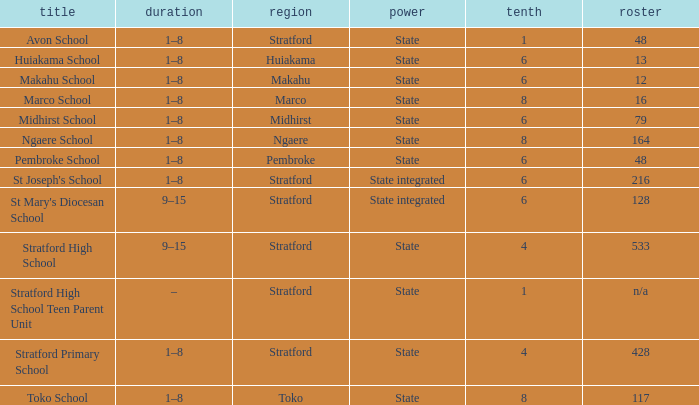What is the lowest decile with a state authority and Midhirst school? 6.0. 